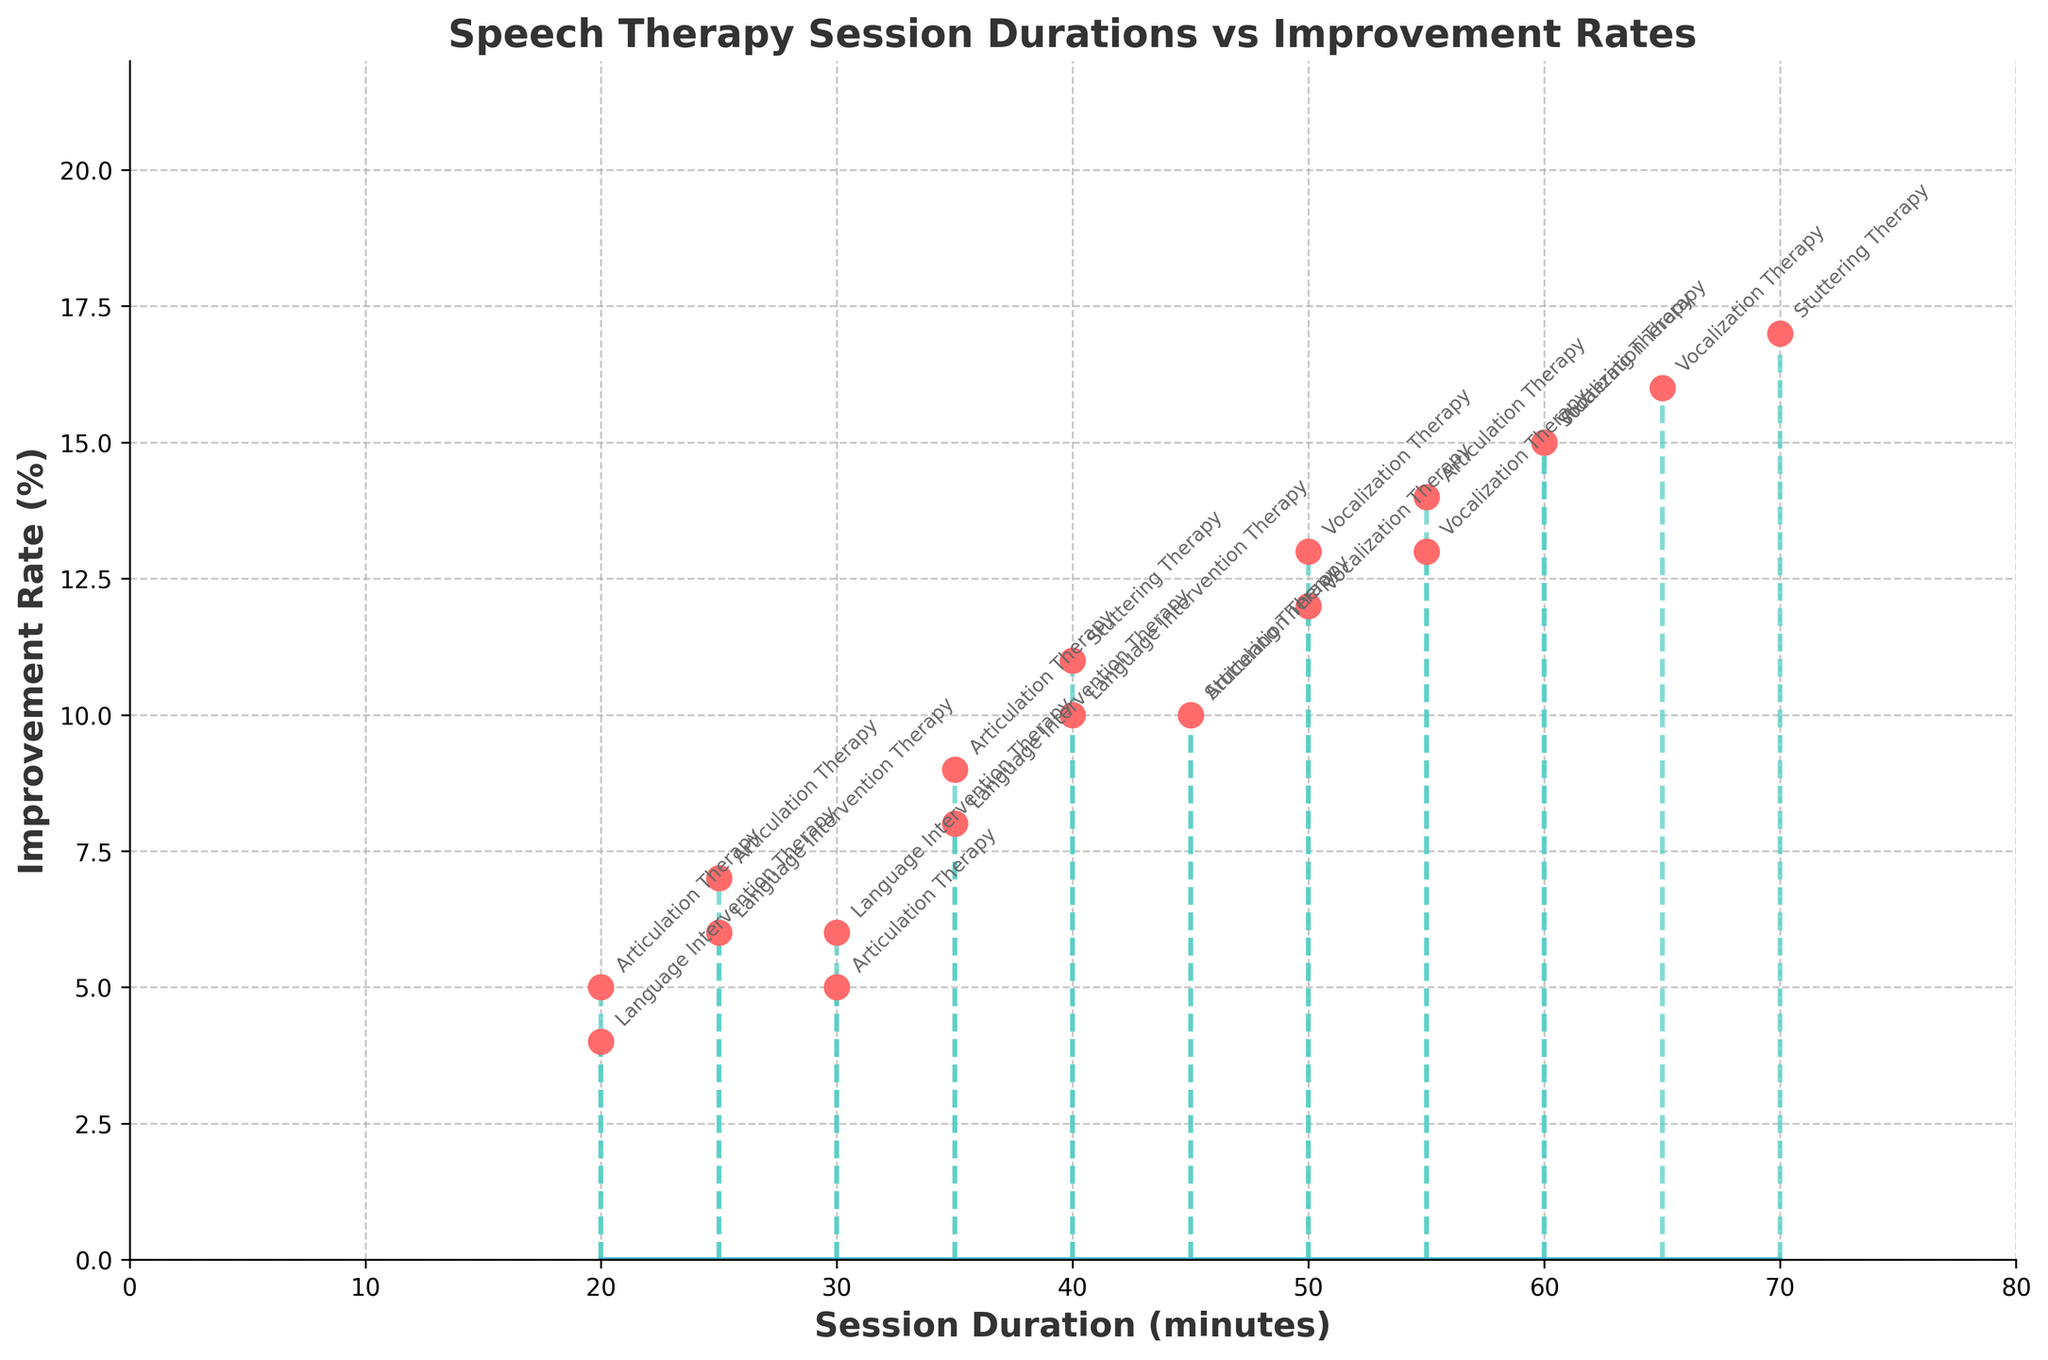What is the title of the figure? The title of the figure is displayed at the top, indicating what the plot is about.
Answer: Speech Therapy Session Durations vs Improvement Rates What are the units for the x-axis and y-axis? The x-axis and y-axis are labeled with units that are clearly indicated.
Answer: Minutes and Percent (%) How many types of therapy are represented in the plot? By counting the different types of annotations next to the stem endpoints, we can determine the number of unique therapies represented.
Answer: Four What is the session duration that corresponds to the highest improvement rate? We identify the tallest stem and read the corresponding x-axis value.
Answer: 70 minutes Which therapy type is associated with the highest improvement rate? We find the highest endpoint of the stems and check the therapy type annotation near it.
Answer: Stuttering Therapy What is the improvement rate for a session duration of 50 minutes? Find the stem endpoint at the 50-minute mark on the x-axis and read the y-axis value.
Answer: 12% and 13% Which has a higher improvement rate: a 40-minute session or a 20-minute session? Locate the stems corresponding to 40 minutes and 20 minutes, then compare their y-axis values.
Answer: 40-minute session What is the median session duration of all therapy types combined? Sort all session durations and find the middle value. The dataset has 20 points, so the median is the average of the 10th and 11th durations.
Answer: 40 minutes What is the average improvement rate for all Stuttering Therapy sessions? Identify all Improvement Rate percentages for Stuttering Therapy, sum them up, and divide by the number of sessions.
Answer: (11 + 10 + 15 + 17) / 4 = 13.25% Does Articulation Therapy generally result in higher improvement rates compared to Language Intervention Therapy? Compare the improvement rates of all sessions labeled Articulation Therapy with those labeled Language Intervention Therapy, and ensure to compare their averages.
Answer: No, Language Intervention Therapy: 7.1667% and Articulation Therapy: 8% 